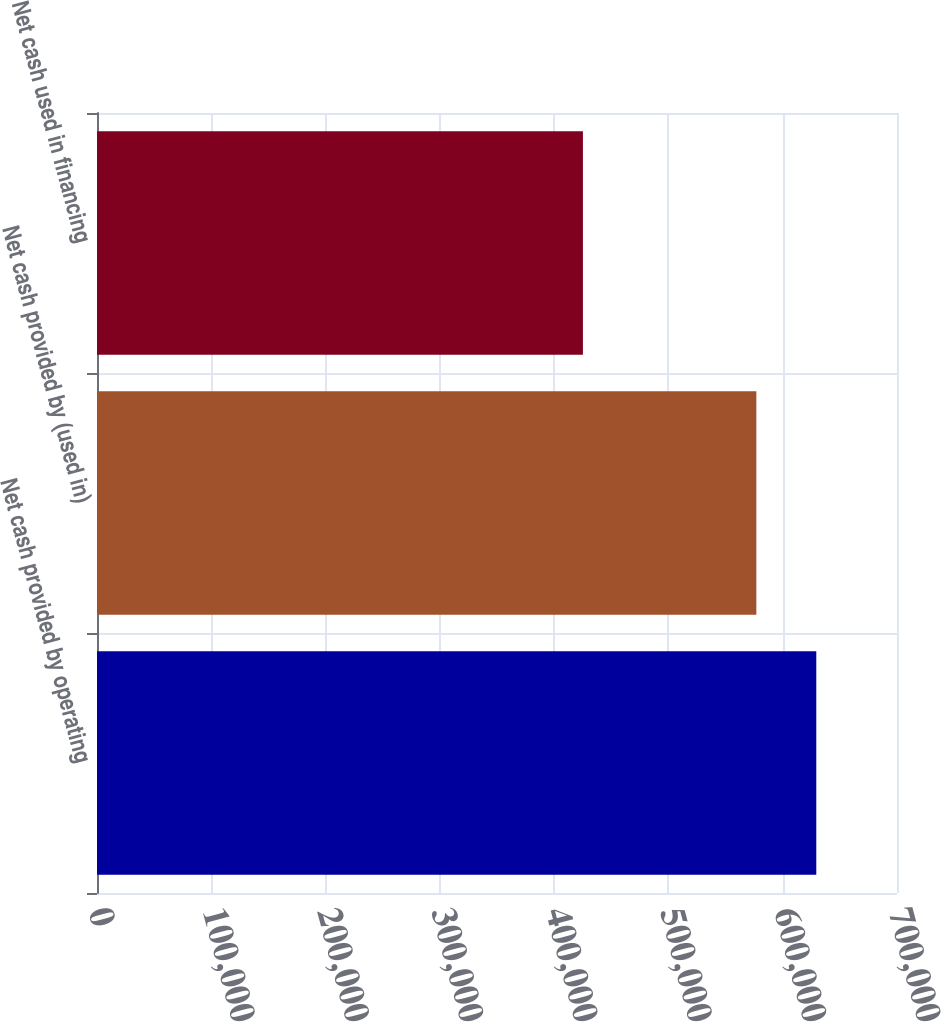Convert chart. <chart><loc_0><loc_0><loc_500><loc_500><bar_chart><fcel>Net cash provided by operating<fcel>Net cash provided by (used in)<fcel>Net cash used in financing<nl><fcel>629378<fcel>576931<fcel>425176<nl></chart> 